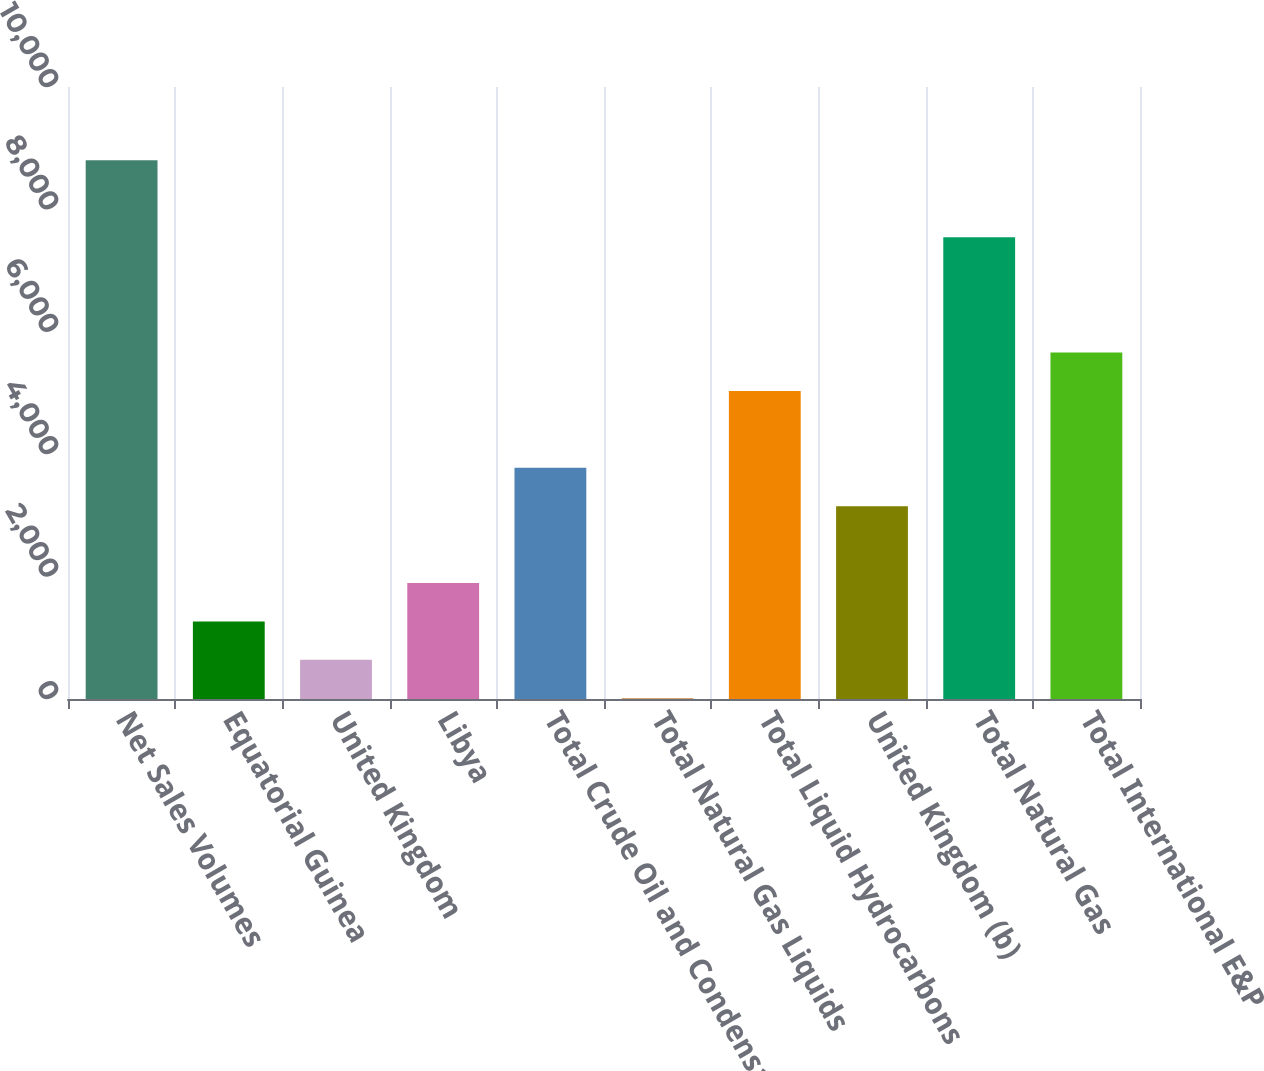Convert chart to OTSL. <chart><loc_0><loc_0><loc_500><loc_500><bar_chart><fcel>Net Sales Volumes<fcel>Equatorial Guinea<fcel>United Kingdom<fcel>Libya<fcel>Total Crude Oil and Condensate<fcel>Total Natural Gas Liquids<fcel>Total Liquid Hydrocarbons<fcel>United Kingdom (b)<fcel>Total Natural Gas<fcel>Total International E&P<nl><fcel>8801.2<fcel>1267.6<fcel>639.8<fcel>1895.4<fcel>3778.8<fcel>12<fcel>5034.4<fcel>3151<fcel>7545.6<fcel>5662.2<nl></chart> 